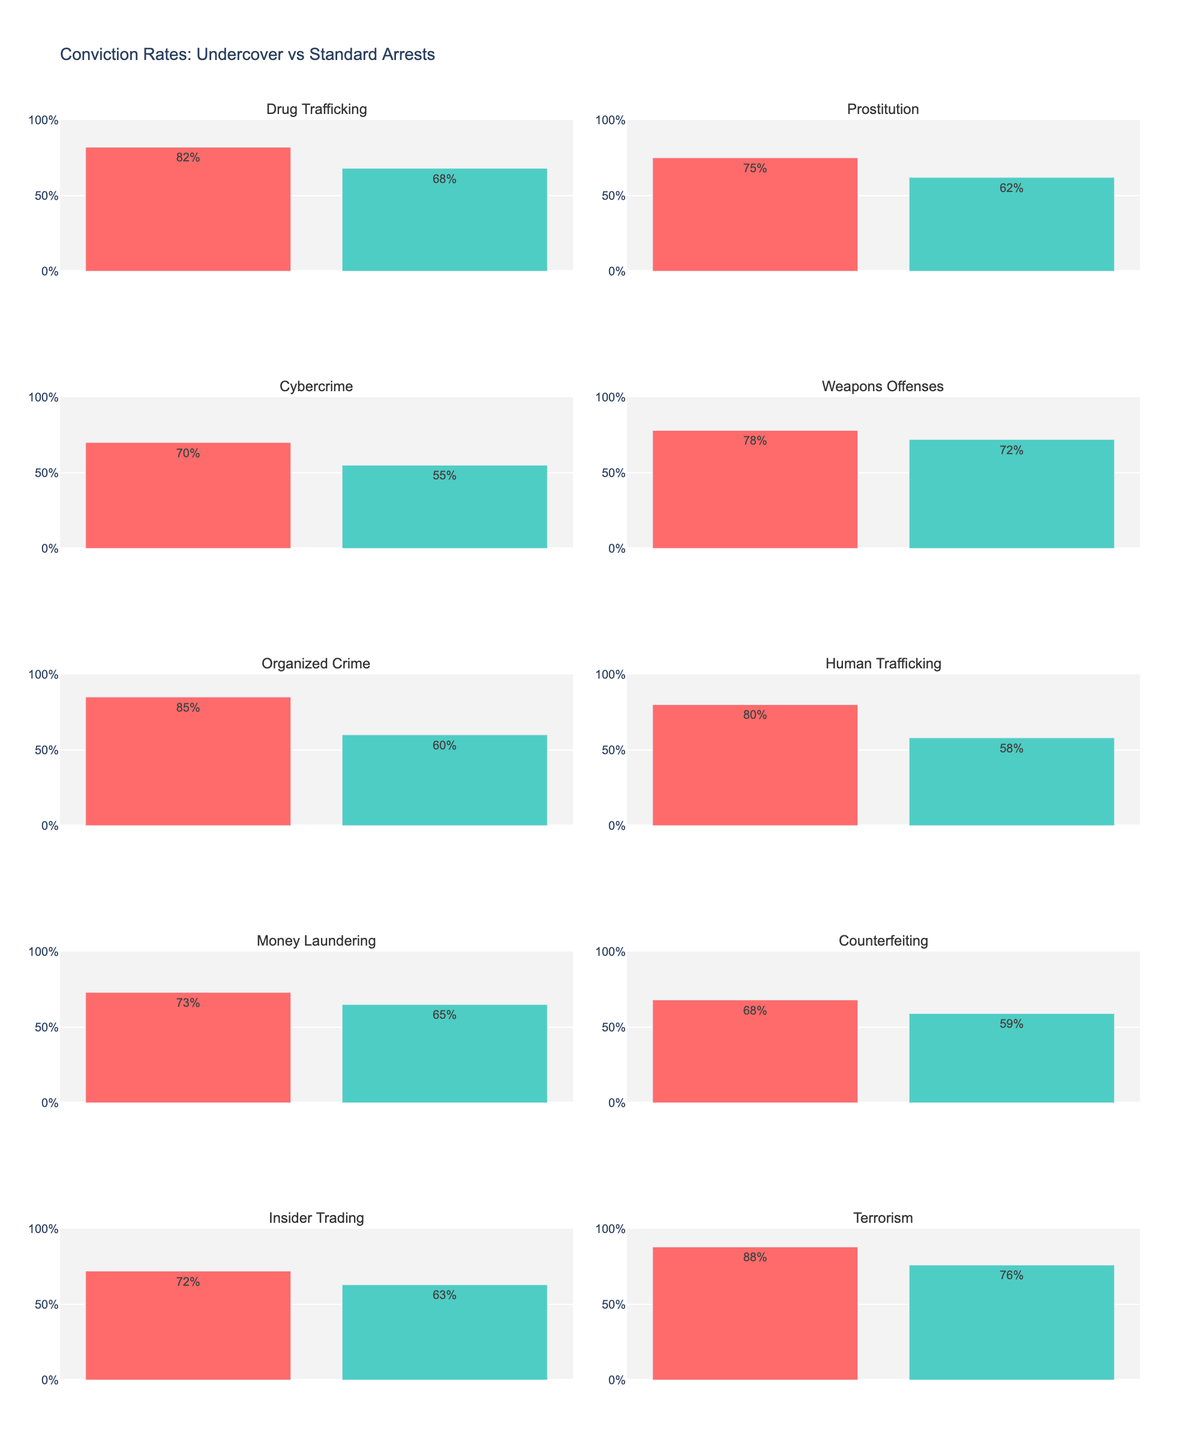Which region shows the highest solar panel efficiency in January? By looking at the subplot titles and the bars representing January in each plot, we can identify which one reaches the highest value.
Answer: Tamil Nadu Which month in Karnataka has the highest efficiency? By focusing on the Karnataka subplot and comparing all the months, we can see that April has the highest efficiency value.
Answer: April How does the efficiency in Gujarat in July compare to that in Rajasthan in July? Locate the Gujarat and Rajasthan subplots and compare the bar heights for July. The efficiency for Gujarat in July is slightly lower than that for Rajasthan.
Answer: Rajasthan is higher What is the range of efficiency values across all regions in April? First, identify the efficiency values for April in each subplot and then determine the range by subtracting the smallest value from the largest. Values: Rajasthan (20.5), Gujarat (20.1), Tamil Nadu (19.7), Karnataka (20.2), Maharashtra (19.9), Madhya Pradesh (20.3). The smallest value is 19.7 and the largest is 20.5, so the range is 20.5 - 19.7.
Answer: 0.8% Comparing Tamil Nadu and Karnataka, which region has a more consistent efficiency across the months? Compare the variations in the heights of the bars across different months in both Tamil Nadu and Karnataka subplots. Tamil Nadu shows less variation compared to Karnataka.
Answer: Tamil Nadu What is the average efficiency for Maharashtra across all listed months? Sum the efficiency values for Maharashtra (17.8, 19.9, 19.1, 18.7) and divide by the number of months (4). (17.8 + 19.9 + 19.1 + 18.7) / 4 = 18.875.
Answer: 18.88% Which region shows the lowest solar panel efficiency in October? By looking at the bars representing October in each subplot, identify the region with the lowest bar. For October: Rajasthan (19.1), Gujarat (18.8), Tamil Nadu (19.3), Karnataka (19.5), Maharashtra (18.7), Madhya Pradesh (18.9). The lowest value is in Maharashtra.
Answer: Maharashtra Does any region show the same efficiency in more than one month? Scan through each region to see if any of them have bars of equal height in different months. No regions show the same efficiency values in more than one month.
Answer: No Which region shows the highest overall efficiency in any single month? Identify the highest bar across all subplots. The highest efficiency value is in Rajasthan during April, which is 20.5%.
Answer: Rajasthan in April How much does the efficiency vary between January and July in Madhya Pradesh? Locate the bars for January and July in the Madhya Pradesh subplot and subtract the January value from the July value. For January (17.6) and July (19.6), the difference is 19.6 - 17.6.
Answer: 2.0% 